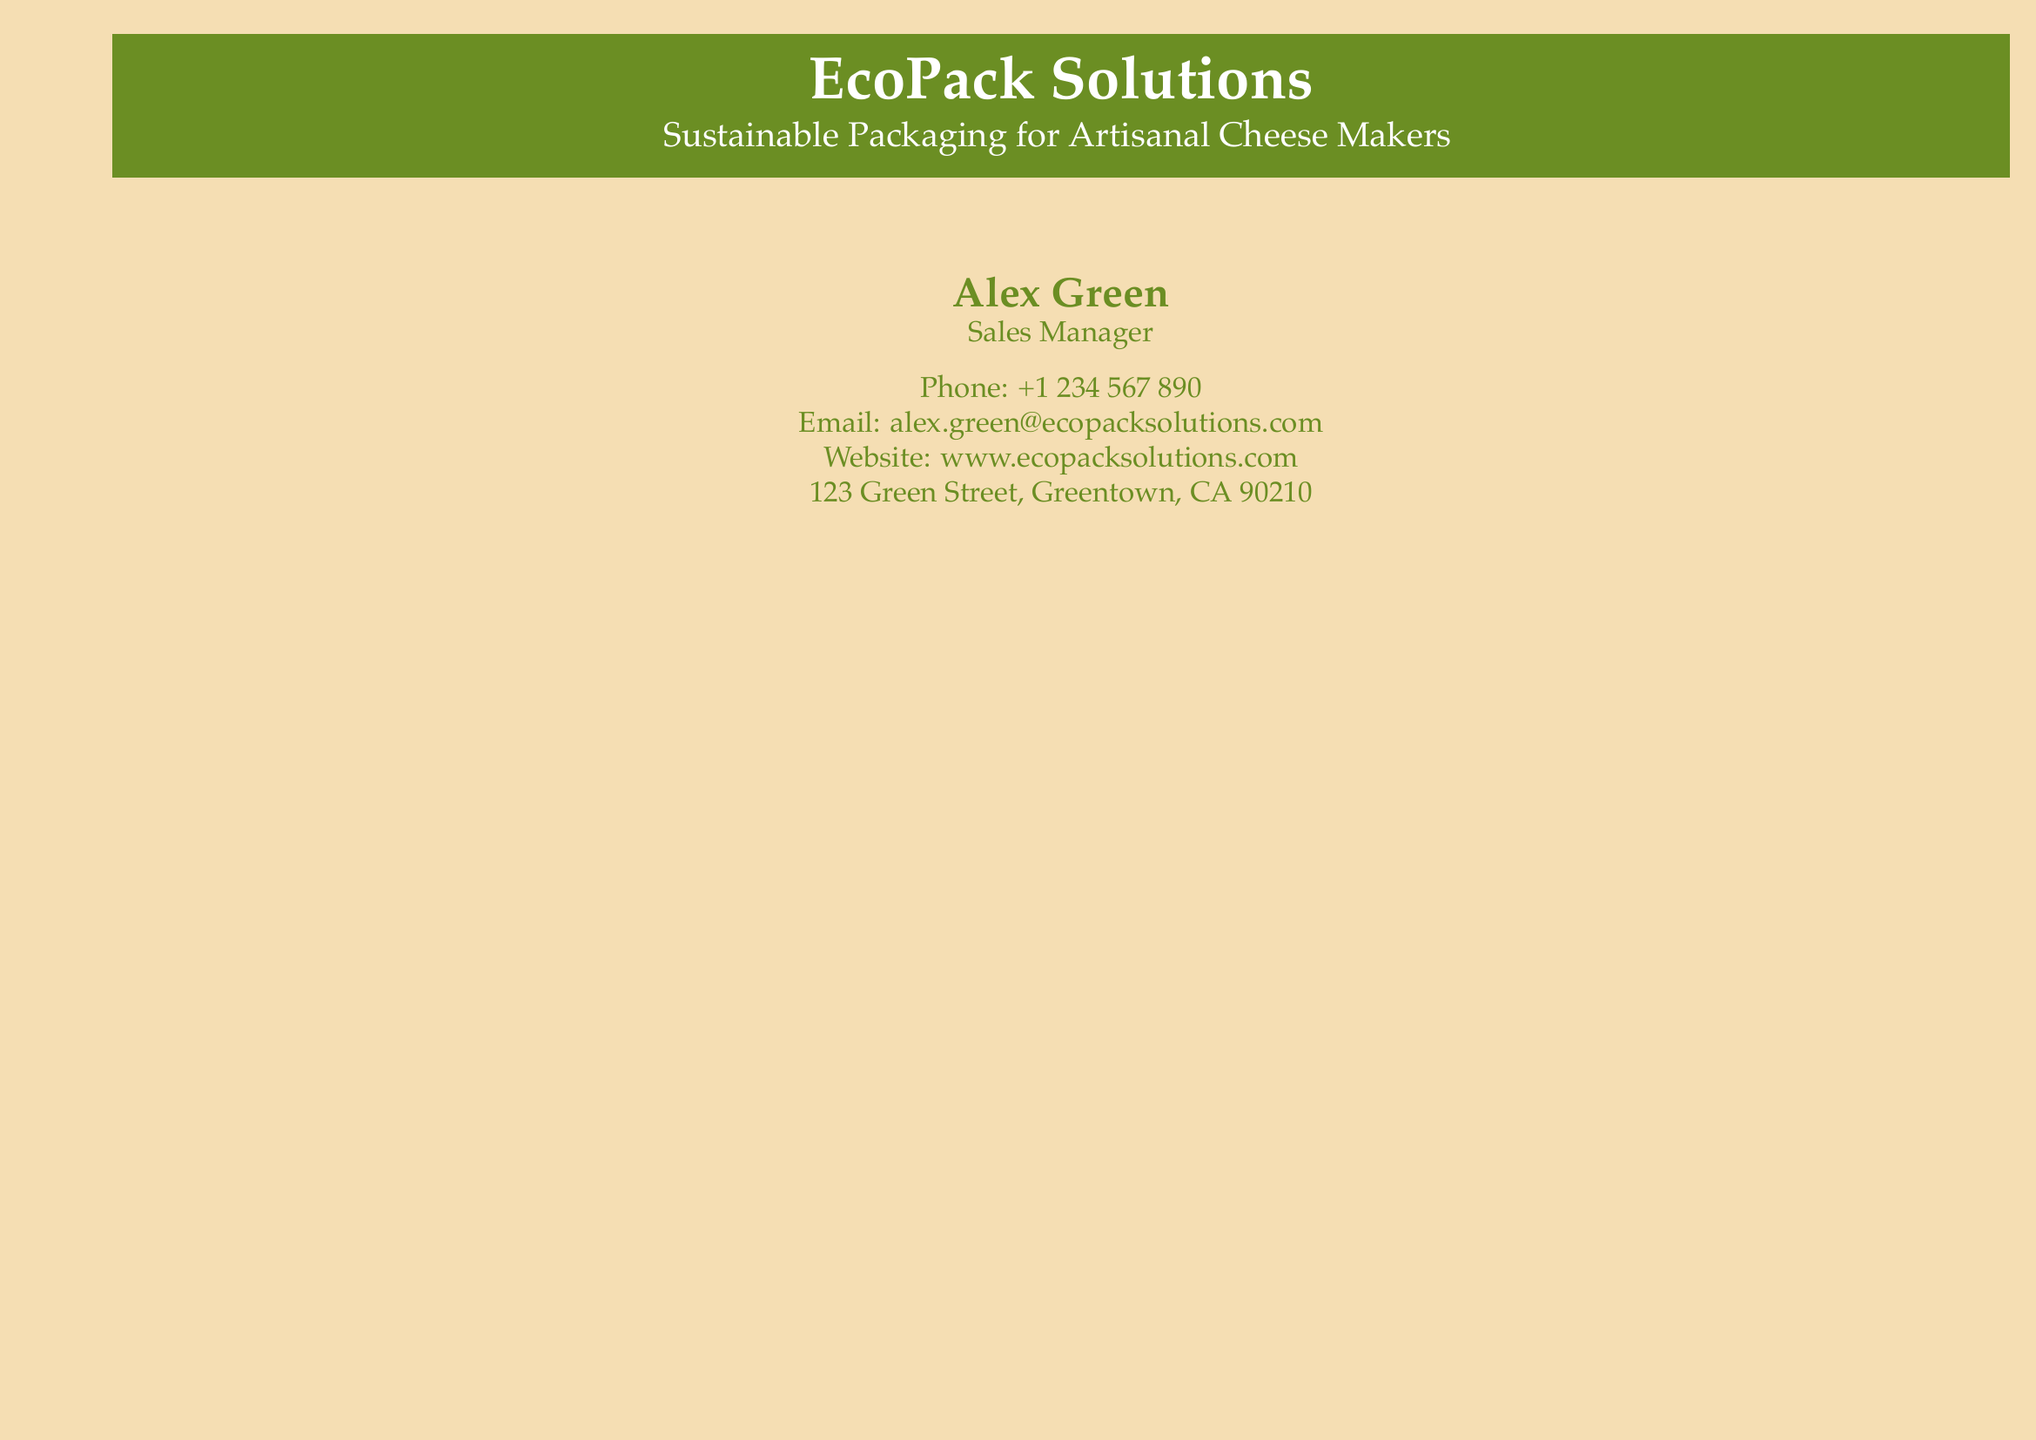What is the name of the company? The company's name is directly mentioned at the top of the business card.
Answer: EcoPack Solutions Who is the Sales Manager? The document clearly states the individual's position and name.
Answer: Alex Green What is the email address provided? The email address is listed in the contact information section.
Answer: alex.green@ecopacksolutions.com How many testimonials are featured? The total number of testimonials can be counted from the testimonial section.
Answer: Four Which testimonial mentions compostable cheese paper? The testimonial that talks about compostable cheese paper includes the individual's name and company.
Answer: Sarah Johnson, Owner, Greenfield Dairy What color scheme is used in the card? The colors used for accents and backgrounds indicate the theme across the entire card.
Answer: Warm green and warm beige What benefit did Michael Brown mention regarding sustainable boxes? The document states what Michael Brown noted about using sustainable boxes for his business.
Answer: Customer satisfaction and loyalty Which cheese maker emphasizes reducing the carbon footprint? The name provided in the testimonial highlights the maker's focus on environmental impact.
Answer: Laura Martinez, Cheese Maker, Bella Fromage What type of packaging does David Lee mention? The testimonial shared by David Lee reflects on the quality of the packaging.
Answer: High-quality and reliable 